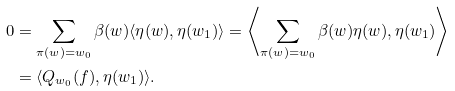Convert formula to latex. <formula><loc_0><loc_0><loc_500><loc_500>0 & = \sum _ { \pi ( w ) = w _ { 0 } } \beta ( w ) \langle \eta ( w ) , \eta ( w _ { 1 } ) \rangle = \left \langle \sum _ { \pi ( w ) = w _ { 0 } } \beta ( w ) \eta ( w ) , \eta ( w _ { 1 } ) \right \rangle \\ & = \langle Q _ { w _ { 0 } } ( f ) , \eta ( w _ { 1 } ) \rangle .</formula> 